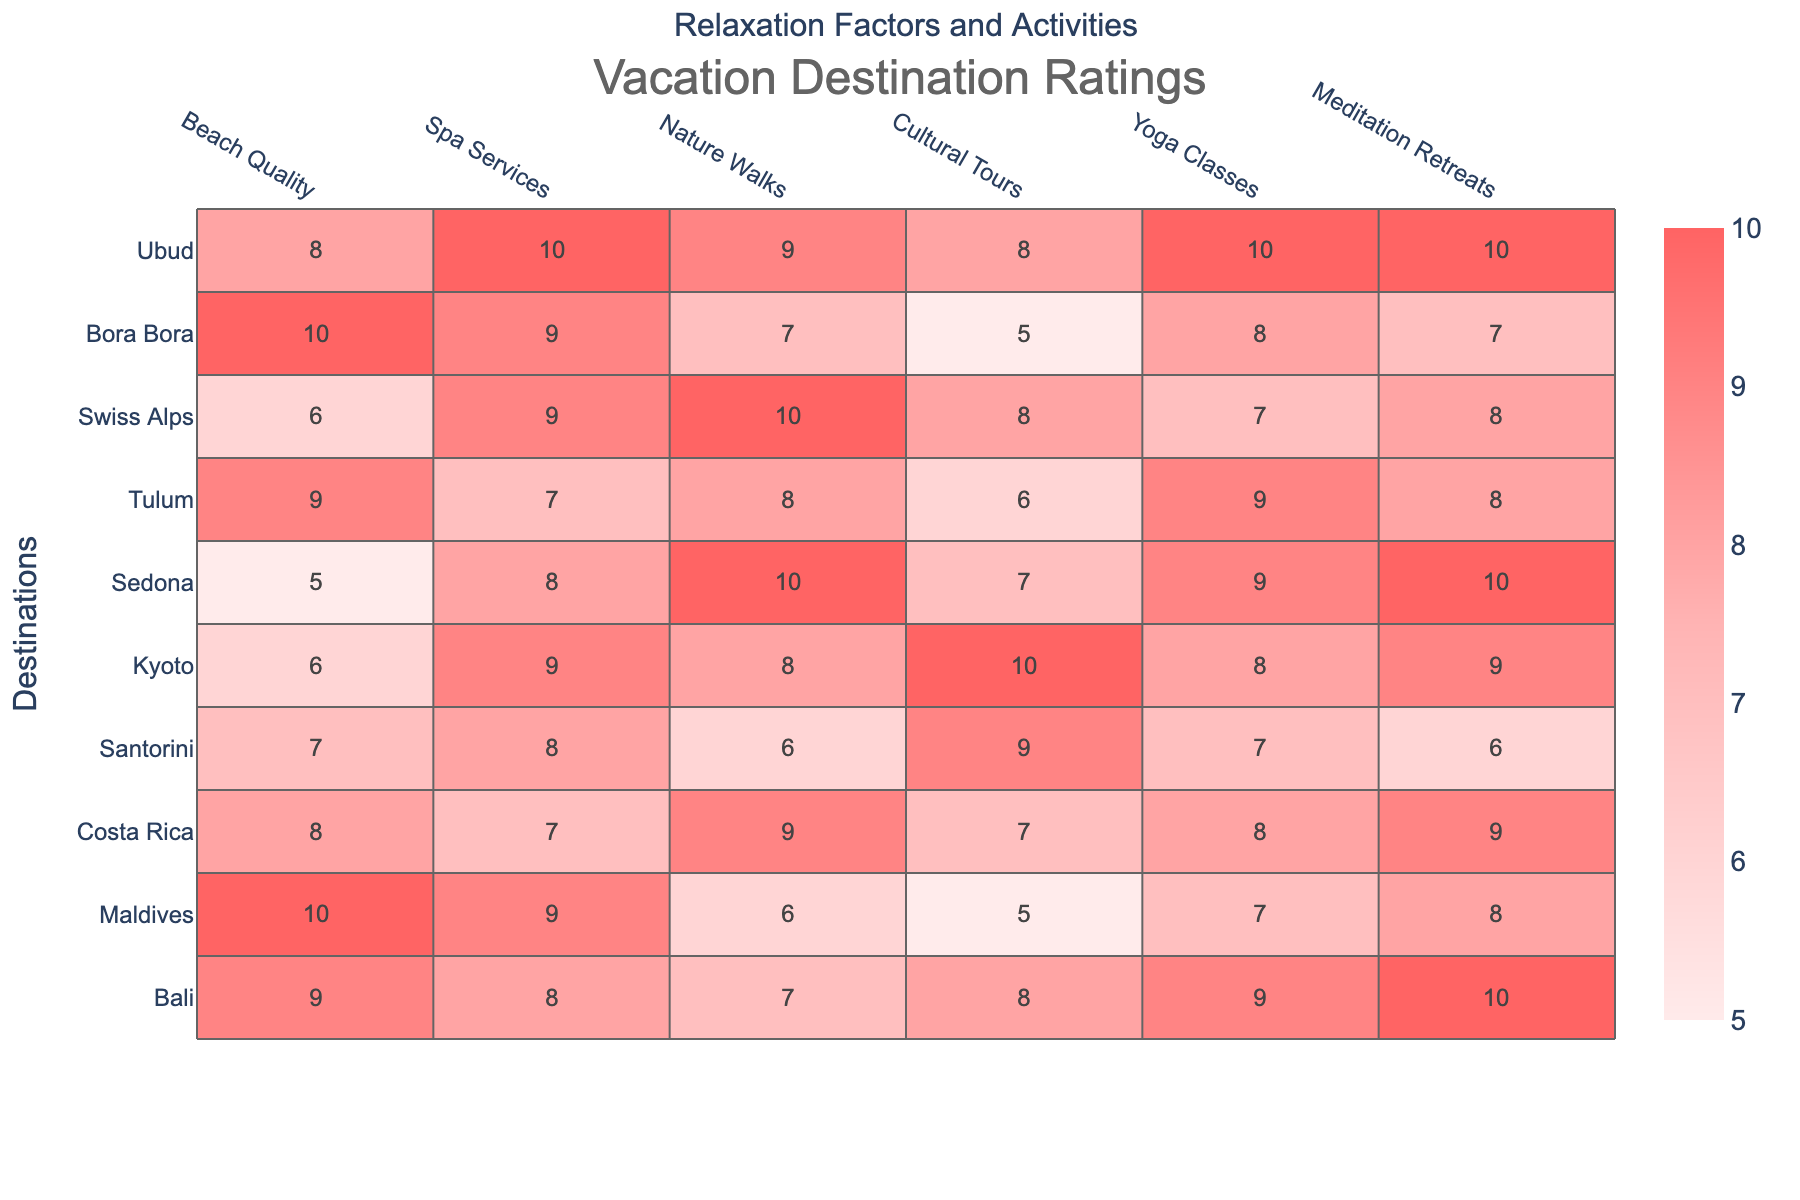What is the highest beach quality rating among the destinations? By reviewing the "Beach Quality" column, the highest rating is 10, which is held by Maldives and Bora Bora.
Answer: 10 Which destination has the best score for meditation retreats? Looking at the "Meditation Retreats" column, both Bali and Ubud have a score of 10, making them the best for this activity.
Answer: 10 What is the average cultural tours rating across all destinations? First, sum the cultural tours ratings: (8 + 5 + 7 + 9 + 10 + 7 + 6 + 8 + 5 + 8) = 69. There are 10 destinations, so the average is 69/10 = 6.9.
Answer: 6.9 Is Sedona known for good yoga classes? Checking the "Yoga Classes" column, Sedona has a rating of 9, which indicates that it is indeed rated highly for yoga classes.
Answer: Yes What is the total score derived from spa services and meditation retreats for Ubud? For Ubud, the scores are 10 (spa services) and 10 (meditation retreats). Adding those gives 10 + 10 = 20.
Answer: 20 Which destination has the lowest overall score in relaxation factors mentioned? Analyzing all columns for each destination, Sedona has a total score of 49, which is the lowest. The scores are 5 (Beach Quality), 8 (Spa Services), 10 (Nature Walks), 7 (Cultural Tours), 9 (Yoga Classes), and 10 (Meditation Retreats) — summing these gives a total of 49.
Answer: Sedona What is the difference in yoga classes rating between Costa Rica and Santorini? Costa Rica has a rating of 8 while Santorini has a rating of 7 for yoga classes. The difference is 8 - 7 = 1.
Answer: 1 How many destinations have a spa services rating greater than 8? By evaluating the "Spa Services" column, the destinations with a rating greater than 8 are Ubud, Maldives, and Kyoto, which totals 3 destinations.
Answer: 3 Which destination offers the least number of relaxation factors with a score below 7? Sedona has several scores below 7, including a beach quality of 5, putting it as having the least number of relaxation factors below 7.
Answer: Sedona 